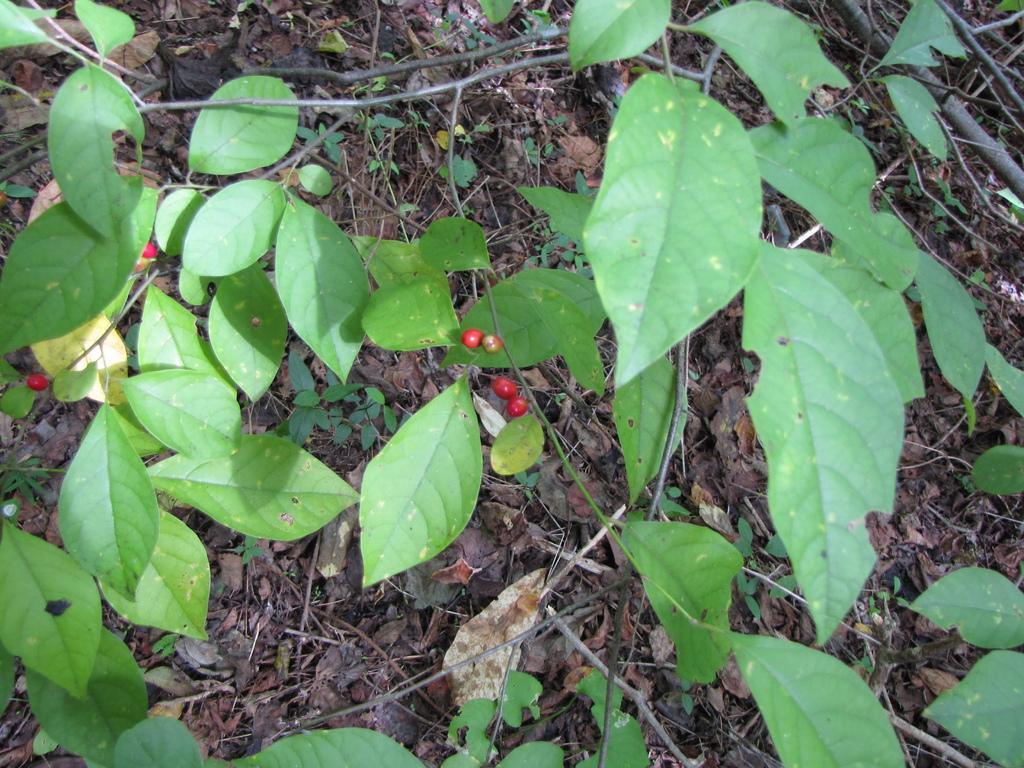In one or two sentences, can you explain what this image depicts? In this image I can see some plant leaves and there are some fruits coming out of this plant. 